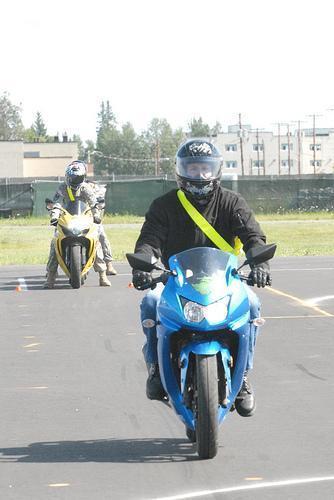How many buffalo are riding motorcycles?
Give a very brief answer. 0. 